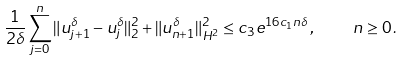<formula> <loc_0><loc_0><loc_500><loc_500>\frac { 1 } { 2 \delta } \sum _ { j = 0 } ^ { n } \| u _ { j + 1 } ^ { \delta } - u _ { j } ^ { \delta } \| _ { 2 } ^ { 2 } + \| u _ { n + 1 } ^ { \delta } \| _ { H ^ { 2 } } ^ { 2 } \leq c _ { 3 } e ^ { 1 6 c _ { 1 } n \delta } \, , \quad n \geq 0 \, .</formula> 